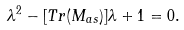<formula> <loc_0><loc_0><loc_500><loc_500>\lambda ^ { 2 } - [ T r ( M _ { a s } ) ] \lambda + 1 = 0 .</formula> 